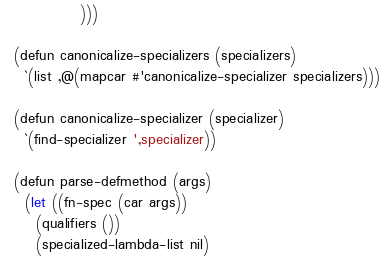<code> <loc_0><loc_0><loc_500><loc_500><_Lisp_>		      )))

  (defun canonicalize-specializers (specializers)
    `(list ,@(mapcar #'canonicalize-specializer specializers)))

  (defun canonicalize-specializer (specializer)
    `(find-specializer ',specializer))

  (defun parse-defmethod (args)
    (let ((fn-spec (car args))
	  (qualifiers ())
	  (specialized-lambda-list nil)</code> 